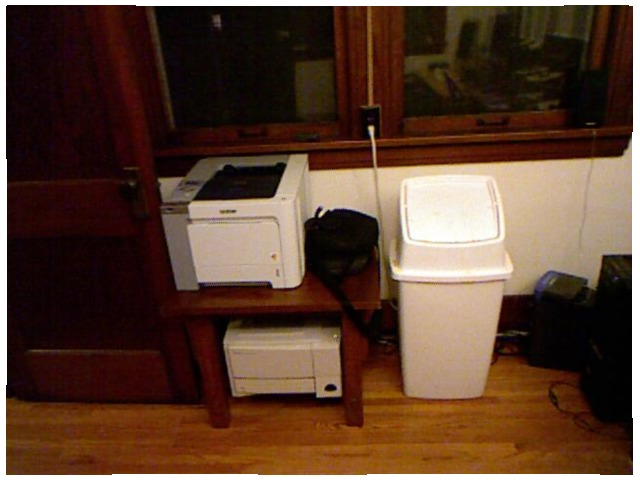<image>
Is the printer under the table? Yes. The printer is positioned underneath the table, with the table above it in the vertical space. Is there a table next to the door? Yes. The table is positioned adjacent to the door, located nearby in the same general area. 